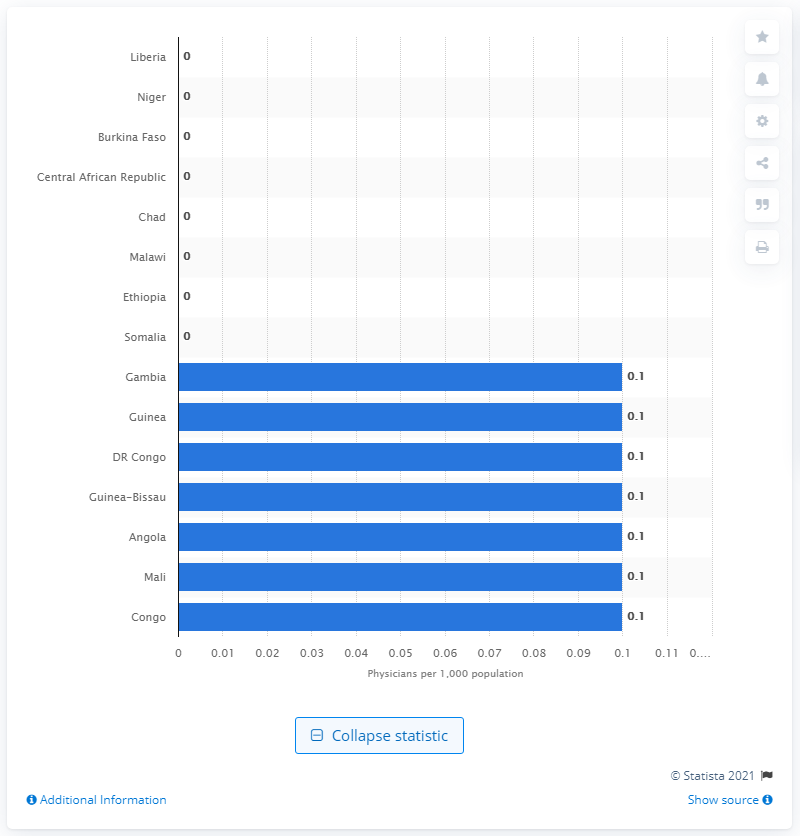Point out several critical features in this image. According to a recent report, the African country of Niger had the lowest number of physicians per 1,000 inhabitants out of all the countries on the continent. This means that the healthcare system in Niger is underfunded and understaffed, potentially leading to a lack of access to medical care for its citizens. 